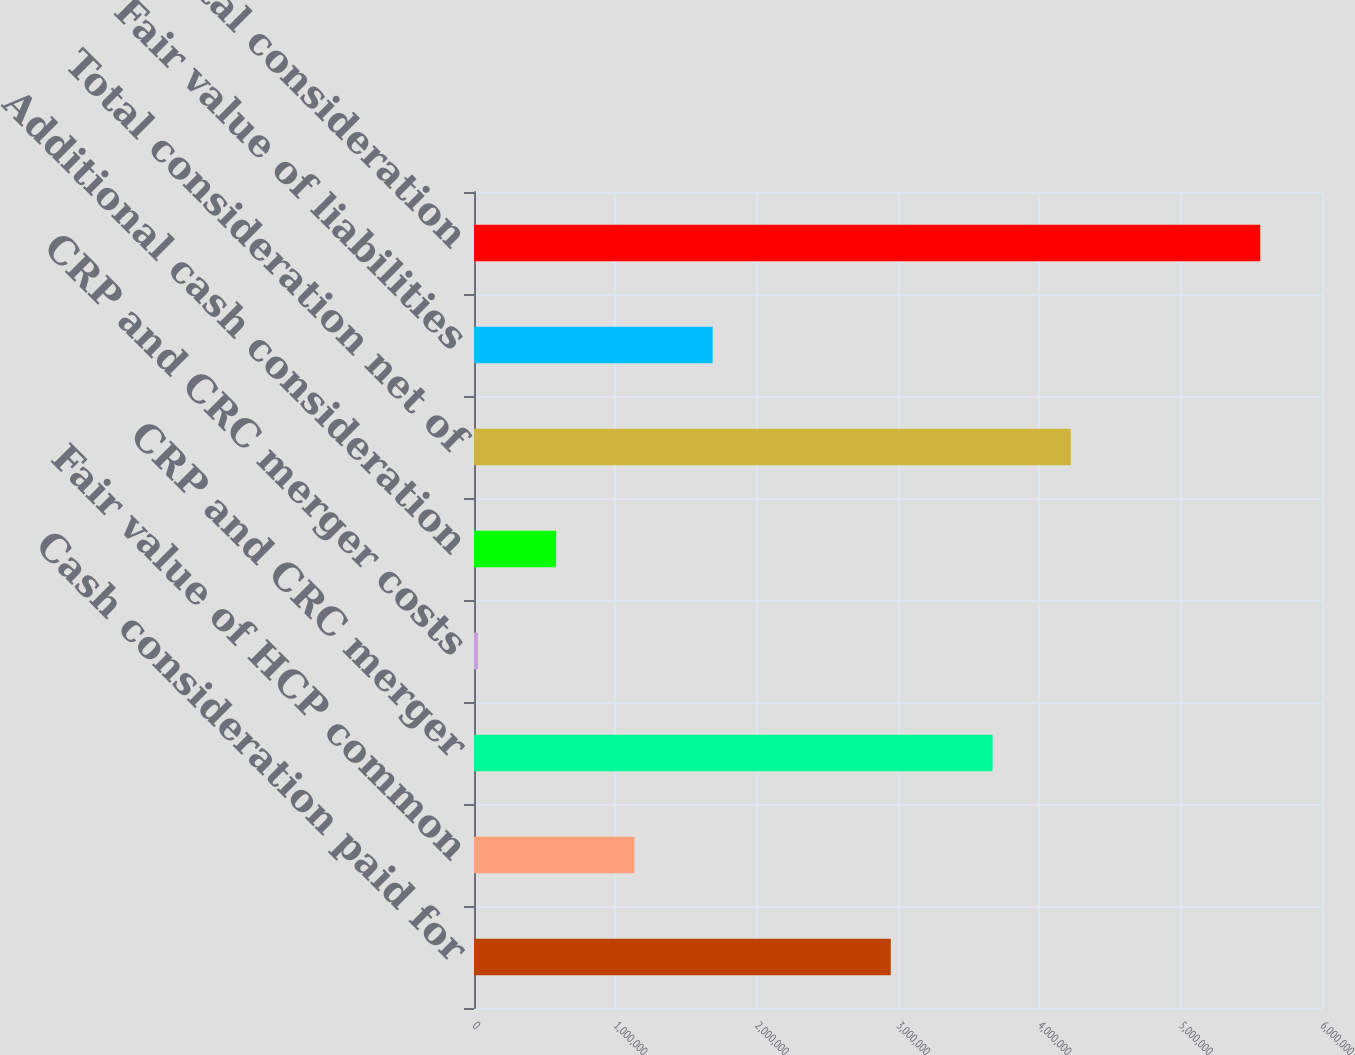Convert chart. <chart><loc_0><loc_0><loc_500><loc_500><bar_chart><fcel>Cash consideration paid for<fcel>Fair value of HCP common<fcel>CRP and CRC merger<fcel>CRP and CRC merger costs<fcel>Additional cash consideration<fcel>Total consideration net of<fcel>Fair value of liabilities<fcel>Total consideration<nl><fcel>2.94873e+06<fcel>1.13499e+06<fcel>3.66911e+06<fcel>27983<fcel>581486<fcel>4.22262e+06<fcel>1.68849e+06<fcel>5.56301e+06<nl></chart> 